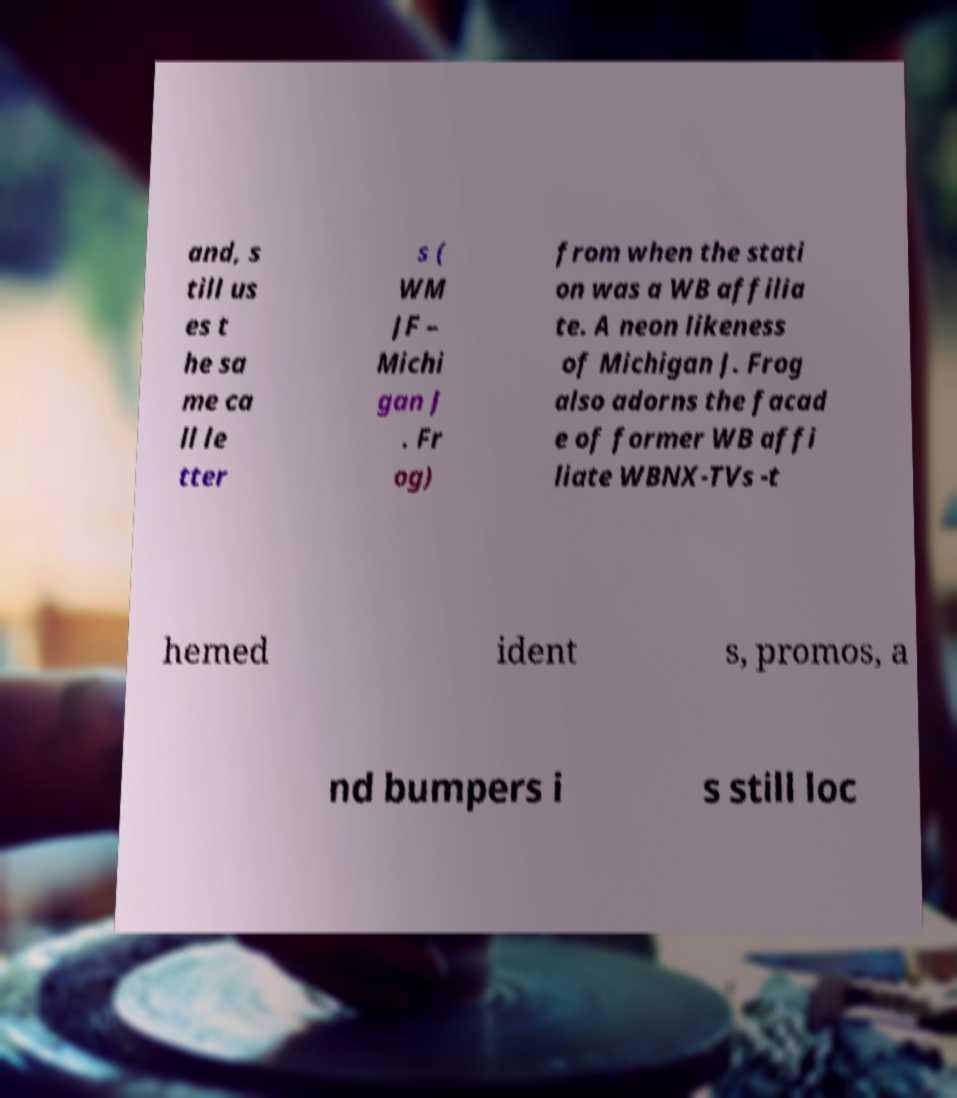Can you accurately transcribe the text from the provided image for me? and, s till us es t he sa me ca ll le tter s ( WM JF – Michi gan J . Fr og) from when the stati on was a WB affilia te. A neon likeness of Michigan J. Frog also adorns the facad e of former WB affi liate WBNX-TVs -t hemed ident s, promos, a nd bumpers i s still loc 